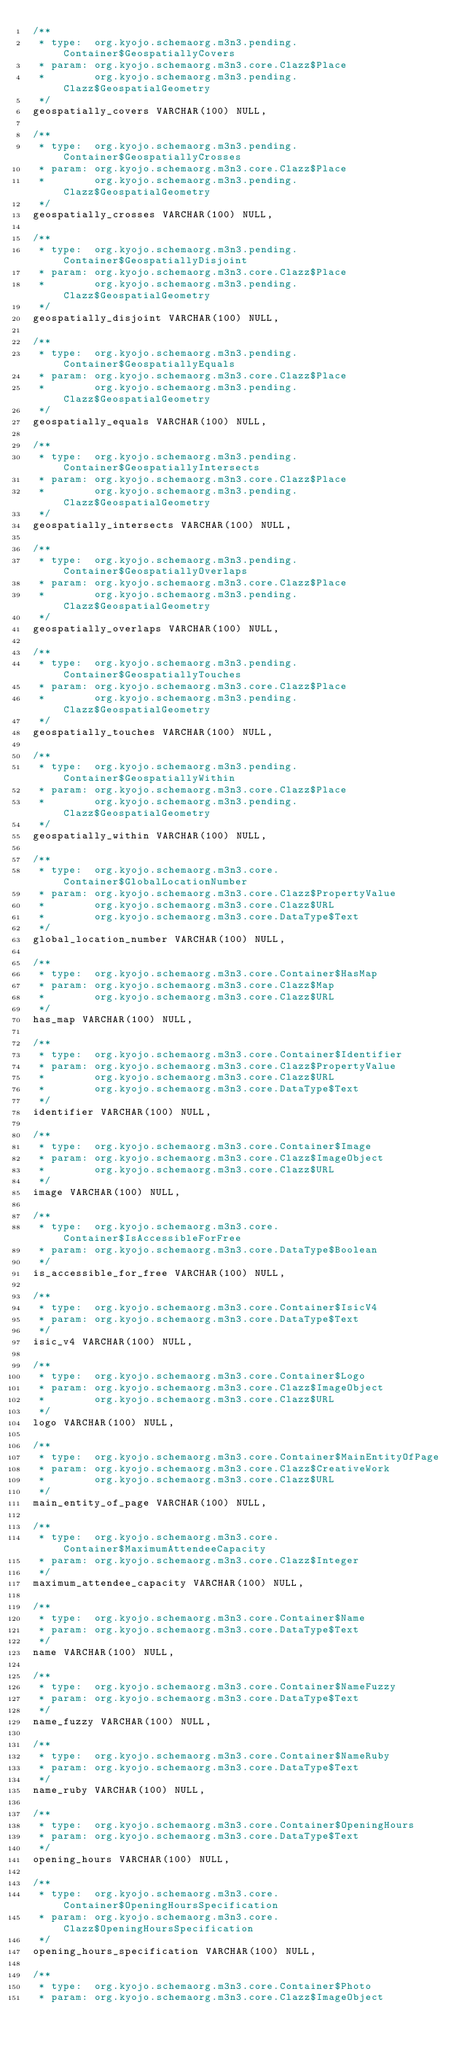Convert code to text. <code><loc_0><loc_0><loc_500><loc_500><_SQL_> /**
  * type:  org.kyojo.schemaorg.m3n3.pending.Container$GeospatiallyCovers
  * param: org.kyojo.schemaorg.m3n3.core.Clazz$Place
  *        org.kyojo.schemaorg.m3n3.pending.Clazz$GeospatialGeometry
  */
 geospatially_covers VARCHAR(100) NULL,

 /**
  * type:  org.kyojo.schemaorg.m3n3.pending.Container$GeospatiallyCrosses
  * param: org.kyojo.schemaorg.m3n3.core.Clazz$Place
  *        org.kyojo.schemaorg.m3n3.pending.Clazz$GeospatialGeometry
  */
 geospatially_crosses VARCHAR(100) NULL,

 /**
  * type:  org.kyojo.schemaorg.m3n3.pending.Container$GeospatiallyDisjoint
  * param: org.kyojo.schemaorg.m3n3.core.Clazz$Place
  *        org.kyojo.schemaorg.m3n3.pending.Clazz$GeospatialGeometry
  */
 geospatially_disjoint VARCHAR(100) NULL,

 /**
  * type:  org.kyojo.schemaorg.m3n3.pending.Container$GeospatiallyEquals
  * param: org.kyojo.schemaorg.m3n3.core.Clazz$Place
  *        org.kyojo.schemaorg.m3n3.pending.Clazz$GeospatialGeometry
  */
 geospatially_equals VARCHAR(100) NULL,

 /**
  * type:  org.kyojo.schemaorg.m3n3.pending.Container$GeospatiallyIntersects
  * param: org.kyojo.schemaorg.m3n3.core.Clazz$Place
  *        org.kyojo.schemaorg.m3n3.pending.Clazz$GeospatialGeometry
  */
 geospatially_intersects VARCHAR(100) NULL,

 /**
  * type:  org.kyojo.schemaorg.m3n3.pending.Container$GeospatiallyOverlaps
  * param: org.kyojo.schemaorg.m3n3.core.Clazz$Place
  *        org.kyojo.schemaorg.m3n3.pending.Clazz$GeospatialGeometry
  */
 geospatially_overlaps VARCHAR(100) NULL,

 /**
  * type:  org.kyojo.schemaorg.m3n3.pending.Container$GeospatiallyTouches
  * param: org.kyojo.schemaorg.m3n3.core.Clazz$Place
  *        org.kyojo.schemaorg.m3n3.pending.Clazz$GeospatialGeometry
  */
 geospatially_touches VARCHAR(100) NULL,

 /**
  * type:  org.kyojo.schemaorg.m3n3.pending.Container$GeospatiallyWithin
  * param: org.kyojo.schemaorg.m3n3.core.Clazz$Place
  *        org.kyojo.schemaorg.m3n3.pending.Clazz$GeospatialGeometry
  */
 geospatially_within VARCHAR(100) NULL,

 /**
  * type:  org.kyojo.schemaorg.m3n3.core.Container$GlobalLocationNumber
  * param: org.kyojo.schemaorg.m3n3.core.Clazz$PropertyValue
  *        org.kyojo.schemaorg.m3n3.core.Clazz$URL
  *        org.kyojo.schemaorg.m3n3.core.DataType$Text
  */
 global_location_number VARCHAR(100) NULL,

 /**
  * type:  org.kyojo.schemaorg.m3n3.core.Container$HasMap
  * param: org.kyojo.schemaorg.m3n3.core.Clazz$Map
  *        org.kyojo.schemaorg.m3n3.core.Clazz$URL
  */
 has_map VARCHAR(100) NULL,

 /**
  * type:  org.kyojo.schemaorg.m3n3.core.Container$Identifier
  * param: org.kyojo.schemaorg.m3n3.core.Clazz$PropertyValue
  *        org.kyojo.schemaorg.m3n3.core.Clazz$URL
  *        org.kyojo.schemaorg.m3n3.core.DataType$Text
  */
 identifier VARCHAR(100) NULL,

 /**
  * type:  org.kyojo.schemaorg.m3n3.core.Container$Image
  * param: org.kyojo.schemaorg.m3n3.core.Clazz$ImageObject
  *        org.kyojo.schemaorg.m3n3.core.Clazz$URL
  */
 image VARCHAR(100) NULL,

 /**
  * type:  org.kyojo.schemaorg.m3n3.core.Container$IsAccessibleForFree
  * param: org.kyojo.schemaorg.m3n3.core.DataType$Boolean
  */
 is_accessible_for_free VARCHAR(100) NULL,

 /**
  * type:  org.kyojo.schemaorg.m3n3.core.Container$IsicV4
  * param: org.kyojo.schemaorg.m3n3.core.DataType$Text
  */
 isic_v4 VARCHAR(100) NULL,

 /**
  * type:  org.kyojo.schemaorg.m3n3.core.Container$Logo
  * param: org.kyojo.schemaorg.m3n3.core.Clazz$ImageObject
  *        org.kyojo.schemaorg.m3n3.core.Clazz$URL
  */
 logo VARCHAR(100) NULL,

 /**
  * type:  org.kyojo.schemaorg.m3n3.core.Container$MainEntityOfPage
  * param: org.kyojo.schemaorg.m3n3.core.Clazz$CreativeWork
  *        org.kyojo.schemaorg.m3n3.core.Clazz$URL
  */
 main_entity_of_page VARCHAR(100) NULL,

 /**
  * type:  org.kyojo.schemaorg.m3n3.core.Container$MaximumAttendeeCapacity
  * param: org.kyojo.schemaorg.m3n3.core.Clazz$Integer
  */
 maximum_attendee_capacity VARCHAR(100) NULL,

 /**
  * type:  org.kyojo.schemaorg.m3n3.core.Container$Name
  * param: org.kyojo.schemaorg.m3n3.core.DataType$Text
  */
 name VARCHAR(100) NULL,

 /**
  * type:  org.kyojo.schemaorg.m3n3.core.Container$NameFuzzy
  * param: org.kyojo.schemaorg.m3n3.core.DataType$Text
  */
 name_fuzzy VARCHAR(100) NULL,

 /**
  * type:  org.kyojo.schemaorg.m3n3.core.Container$NameRuby
  * param: org.kyojo.schemaorg.m3n3.core.DataType$Text
  */
 name_ruby VARCHAR(100) NULL,

 /**
  * type:  org.kyojo.schemaorg.m3n3.core.Container$OpeningHours
  * param: org.kyojo.schemaorg.m3n3.core.DataType$Text
  */
 opening_hours VARCHAR(100) NULL,

 /**
  * type:  org.kyojo.schemaorg.m3n3.core.Container$OpeningHoursSpecification
  * param: org.kyojo.schemaorg.m3n3.core.Clazz$OpeningHoursSpecification
  */
 opening_hours_specification VARCHAR(100) NULL,

 /**
  * type:  org.kyojo.schemaorg.m3n3.core.Container$Photo
  * param: org.kyojo.schemaorg.m3n3.core.Clazz$ImageObject</code> 